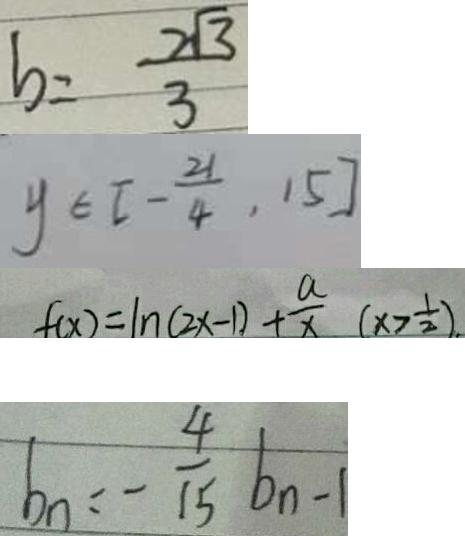Convert formula to latex. <formula><loc_0><loc_0><loc_500><loc_500>b = \frac { 2 \sqrt { 3 } } { 3 } 
 y \in [ - \frac { 2 1 } { 4 } , 1 5 ] 
 f ( x ) = \ln ( 2 x - 1 ) + \frac { a } { x } ( x > \frac { 1 } { 2 } ) . 
 b _ { n } = - \frac { 4 } { 1 5 } b _ { n - 1 }</formula> 